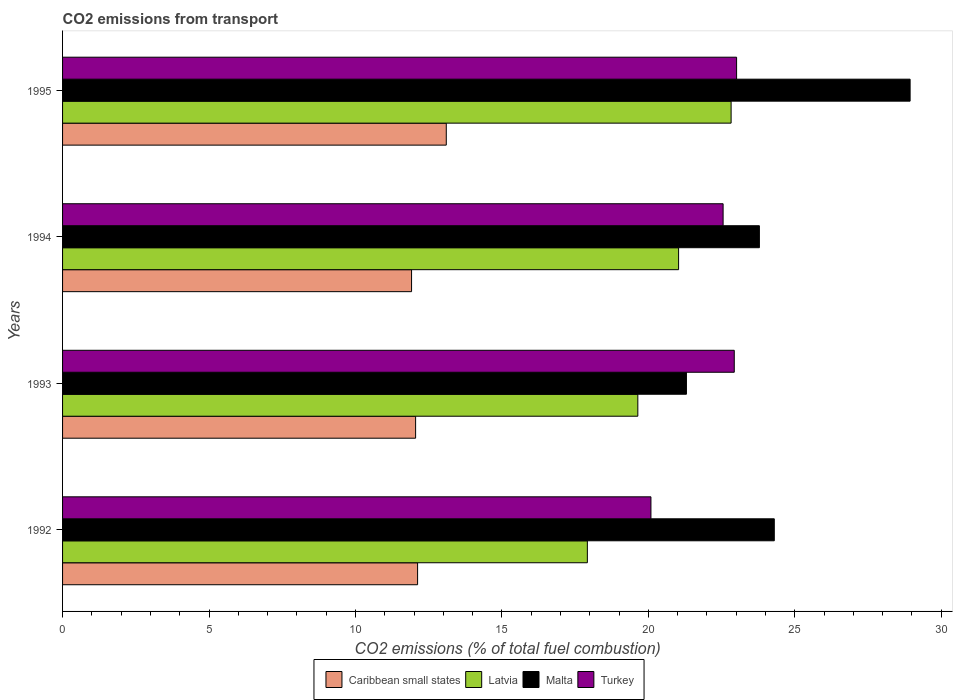How many different coloured bars are there?
Give a very brief answer. 4. How many groups of bars are there?
Offer a very short reply. 4. How many bars are there on the 4th tick from the top?
Offer a terse response. 4. What is the total CO2 emitted in Caribbean small states in 1994?
Provide a short and direct response. 11.92. Across all years, what is the maximum total CO2 emitted in Latvia?
Your answer should be compact. 22.82. Across all years, what is the minimum total CO2 emitted in Caribbean small states?
Your response must be concise. 11.92. In which year was the total CO2 emitted in Malta minimum?
Your answer should be very brief. 1993. What is the total total CO2 emitted in Turkey in the graph?
Your answer should be very brief. 88.58. What is the difference between the total CO2 emitted in Latvia in 1992 and that in 1993?
Ensure brevity in your answer.  -1.72. What is the difference between the total CO2 emitted in Latvia in 1994 and the total CO2 emitted in Malta in 1993?
Provide a succinct answer. -0.27. What is the average total CO2 emitted in Turkey per year?
Make the answer very short. 22.15. In the year 1994, what is the difference between the total CO2 emitted in Caribbean small states and total CO2 emitted in Latvia?
Provide a short and direct response. -9.12. What is the ratio of the total CO2 emitted in Malta in 1993 to that in 1995?
Keep it short and to the point. 0.74. Is the total CO2 emitted in Caribbean small states in 1993 less than that in 1994?
Keep it short and to the point. No. Is the difference between the total CO2 emitted in Caribbean small states in 1993 and 1994 greater than the difference between the total CO2 emitted in Latvia in 1993 and 1994?
Offer a very short reply. Yes. What is the difference between the highest and the second highest total CO2 emitted in Malta?
Provide a short and direct response. 4.64. What is the difference between the highest and the lowest total CO2 emitted in Latvia?
Your answer should be very brief. 4.91. Is the sum of the total CO2 emitted in Turkey in 1992 and 1995 greater than the maximum total CO2 emitted in Latvia across all years?
Provide a short and direct response. Yes. What does the 3rd bar from the top in 1995 represents?
Your response must be concise. Latvia. What does the 1st bar from the bottom in 1992 represents?
Provide a short and direct response. Caribbean small states. Are the values on the major ticks of X-axis written in scientific E-notation?
Your answer should be compact. No. Does the graph contain any zero values?
Give a very brief answer. No. Where does the legend appear in the graph?
Ensure brevity in your answer.  Bottom center. How are the legend labels stacked?
Your answer should be compact. Horizontal. What is the title of the graph?
Provide a short and direct response. CO2 emissions from transport. What is the label or title of the X-axis?
Keep it short and to the point. CO2 emissions (% of total fuel combustion). What is the label or title of the Y-axis?
Ensure brevity in your answer.  Years. What is the CO2 emissions (% of total fuel combustion) in Caribbean small states in 1992?
Ensure brevity in your answer.  12.12. What is the CO2 emissions (% of total fuel combustion) in Latvia in 1992?
Make the answer very short. 17.92. What is the CO2 emissions (% of total fuel combustion) of Malta in 1992?
Keep it short and to the point. 24.3. What is the CO2 emissions (% of total fuel combustion) of Turkey in 1992?
Ensure brevity in your answer.  20.09. What is the CO2 emissions (% of total fuel combustion) in Caribbean small states in 1993?
Give a very brief answer. 12.05. What is the CO2 emissions (% of total fuel combustion) of Latvia in 1993?
Make the answer very short. 19.64. What is the CO2 emissions (% of total fuel combustion) of Malta in 1993?
Offer a terse response. 21.3. What is the CO2 emissions (% of total fuel combustion) in Turkey in 1993?
Make the answer very short. 22.93. What is the CO2 emissions (% of total fuel combustion) in Caribbean small states in 1994?
Offer a terse response. 11.92. What is the CO2 emissions (% of total fuel combustion) of Latvia in 1994?
Your answer should be very brief. 21.03. What is the CO2 emissions (% of total fuel combustion) of Malta in 1994?
Offer a terse response. 23.79. What is the CO2 emissions (% of total fuel combustion) in Turkey in 1994?
Provide a short and direct response. 22.55. What is the CO2 emissions (% of total fuel combustion) in Caribbean small states in 1995?
Offer a terse response. 13.1. What is the CO2 emissions (% of total fuel combustion) of Latvia in 1995?
Your response must be concise. 22.82. What is the CO2 emissions (% of total fuel combustion) of Malta in 1995?
Your response must be concise. 28.94. What is the CO2 emissions (% of total fuel combustion) of Turkey in 1995?
Your answer should be compact. 23.01. Across all years, what is the maximum CO2 emissions (% of total fuel combustion) of Caribbean small states?
Your answer should be compact. 13.1. Across all years, what is the maximum CO2 emissions (% of total fuel combustion) in Latvia?
Provide a succinct answer. 22.82. Across all years, what is the maximum CO2 emissions (% of total fuel combustion) of Malta?
Provide a succinct answer. 28.94. Across all years, what is the maximum CO2 emissions (% of total fuel combustion) in Turkey?
Keep it short and to the point. 23.01. Across all years, what is the minimum CO2 emissions (% of total fuel combustion) in Caribbean small states?
Provide a succinct answer. 11.92. Across all years, what is the minimum CO2 emissions (% of total fuel combustion) in Latvia?
Offer a very short reply. 17.92. Across all years, what is the minimum CO2 emissions (% of total fuel combustion) in Malta?
Give a very brief answer. 21.3. Across all years, what is the minimum CO2 emissions (% of total fuel combustion) in Turkey?
Your response must be concise. 20.09. What is the total CO2 emissions (% of total fuel combustion) in Caribbean small states in the graph?
Your answer should be very brief. 49.19. What is the total CO2 emissions (% of total fuel combustion) in Latvia in the graph?
Offer a terse response. 81.41. What is the total CO2 emissions (% of total fuel combustion) of Malta in the graph?
Make the answer very short. 98.33. What is the total CO2 emissions (% of total fuel combustion) of Turkey in the graph?
Offer a terse response. 88.58. What is the difference between the CO2 emissions (% of total fuel combustion) of Caribbean small states in 1992 and that in 1993?
Provide a short and direct response. 0.07. What is the difference between the CO2 emissions (% of total fuel combustion) in Latvia in 1992 and that in 1993?
Your answer should be compact. -1.72. What is the difference between the CO2 emissions (% of total fuel combustion) of Malta in 1992 and that in 1993?
Ensure brevity in your answer.  3. What is the difference between the CO2 emissions (% of total fuel combustion) in Turkey in 1992 and that in 1993?
Your answer should be very brief. -2.84. What is the difference between the CO2 emissions (% of total fuel combustion) of Caribbean small states in 1992 and that in 1994?
Your answer should be very brief. 0.21. What is the difference between the CO2 emissions (% of total fuel combustion) in Latvia in 1992 and that in 1994?
Provide a succinct answer. -3.11. What is the difference between the CO2 emissions (% of total fuel combustion) of Malta in 1992 and that in 1994?
Ensure brevity in your answer.  0.51. What is the difference between the CO2 emissions (% of total fuel combustion) of Turkey in 1992 and that in 1994?
Your answer should be very brief. -2.46. What is the difference between the CO2 emissions (% of total fuel combustion) of Caribbean small states in 1992 and that in 1995?
Make the answer very short. -0.98. What is the difference between the CO2 emissions (% of total fuel combustion) of Latvia in 1992 and that in 1995?
Ensure brevity in your answer.  -4.91. What is the difference between the CO2 emissions (% of total fuel combustion) of Malta in 1992 and that in 1995?
Your answer should be compact. -4.64. What is the difference between the CO2 emissions (% of total fuel combustion) of Turkey in 1992 and that in 1995?
Provide a short and direct response. -2.92. What is the difference between the CO2 emissions (% of total fuel combustion) of Caribbean small states in 1993 and that in 1994?
Your answer should be compact. 0.14. What is the difference between the CO2 emissions (% of total fuel combustion) of Latvia in 1993 and that in 1994?
Give a very brief answer. -1.39. What is the difference between the CO2 emissions (% of total fuel combustion) of Malta in 1993 and that in 1994?
Your response must be concise. -2.49. What is the difference between the CO2 emissions (% of total fuel combustion) in Turkey in 1993 and that in 1994?
Provide a short and direct response. 0.38. What is the difference between the CO2 emissions (% of total fuel combustion) in Caribbean small states in 1993 and that in 1995?
Provide a short and direct response. -1.05. What is the difference between the CO2 emissions (% of total fuel combustion) in Latvia in 1993 and that in 1995?
Ensure brevity in your answer.  -3.19. What is the difference between the CO2 emissions (% of total fuel combustion) of Malta in 1993 and that in 1995?
Offer a very short reply. -7.64. What is the difference between the CO2 emissions (% of total fuel combustion) in Turkey in 1993 and that in 1995?
Offer a very short reply. -0.08. What is the difference between the CO2 emissions (% of total fuel combustion) in Caribbean small states in 1994 and that in 1995?
Provide a succinct answer. -1.19. What is the difference between the CO2 emissions (% of total fuel combustion) in Latvia in 1994 and that in 1995?
Offer a terse response. -1.79. What is the difference between the CO2 emissions (% of total fuel combustion) in Malta in 1994 and that in 1995?
Offer a terse response. -5.15. What is the difference between the CO2 emissions (% of total fuel combustion) of Turkey in 1994 and that in 1995?
Make the answer very short. -0.46. What is the difference between the CO2 emissions (% of total fuel combustion) of Caribbean small states in 1992 and the CO2 emissions (% of total fuel combustion) of Latvia in 1993?
Give a very brief answer. -7.52. What is the difference between the CO2 emissions (% of total fuel combustion) in Caribbean small states in 1992 and the CO2 emissions (% of total fuel combustion) in Malta in 1993?
Make the answer very short. -9.18. What is the difference between the CO2 emissions (% of total fuel combustion) of Caribbean small states in 1992 and the CO2 emissions (% of total fuel combustion) of Turkey in 1993?
Provide a short and direct response. -10.81. What is the difference between the CO2 emissions (% of total fuel combustion) in Latvia in 1992 and the CO2 emissions (% of total fuel combustion) in Malta in 1993?
Keep it short and to the point. -3.38. What is the difference between the CO2 emissions (% of total fuel combustion) in Latvia in 1992 and the CO2 emissions (% of total fuel combustion) in Turkey in 1993?
Your answer should be compact. -5.02. What is the difference between the CO2 emissions (% of total fuel combustion) of Malta in 1992 and the CO2 emissions (% of total fuel combustion) of Turkey in 1993?
Your response must be concise. 1.37. What is the difference between the CO2 emissions (% of total fuel combustion) in Caribbean small states in 1992 and the CO2 emissions (% of total fuel combustion) in Latvia in 1994?
Your answer should be compact. -8.91. What is the difference between the CO2 emissions (% of total fuel combustion) in Caribbean small states in 1992 and the CO2 emissions (% of total fuel combustion) in Malta in 1994?
Give a very brief answer. -11.67. What is the difference between the CO2 emissions (% of total fuel combustion) in Caribbean small states in 1992 and the CO2 emissions (% of total fuel combustion) in Turkey in 1994?
Make the answer very short. -10.43. What is the difference between the CO2 emissions (% of total fuel combustion) of Latvia in 1992 and the CO2 emissions (% of total fuel combustion) of Malta in 1994?
Make the answer very short. -5.87. What is the difference between the CO2 emissions (% of total fuel combustion) in Latvia in 1992 and the CO2 emissions (% of total fuel combustion) in Turkey in 1994?
Ensure brevity in your answer.  -4.63. What is the difference between the CO2 emissions (% of total fuel combustion) in Malta in 1992 and the CO2 emissions (% of total fuel combustion) in Turkey in 1994?
Offer a very short reply. 1.75. What is the difference between the CO2 emissions (% of total fuel combustion) of Caribbean small states in 1992 and the CO2 emissions (% of total fuel combustion) of Latvia in 1995?
Ensure brevity in your answer.  -10.7. What is the difference between the CO2 emissions (% of total fuel combustion) of Caribbean small states in 1992 and the CO2 emissions (% of total fuel combustion) of Malta in 1995?
Give a very brief answer. -16.82. What is the difference between the CO2 emissions (% of total fuel combustion) in Caribbean small states in 1992 and the CO2 emissions (% of total fuel combustion) in Turkey in 1995?
Keep it short and to the point. -10.89. What is the difference between the CO2 emissions (% of total fuel combustion) in Latvia in 1992 and the CO2 emissions (% of total fuel combustion) in Malta in 1995?
Offer a terse response. -11.02. What is the difference between the CO2 emissions (% of total fuel combustion) of Latvia in 1992 and the CO2 emissions (% of total fuel combustion) of Turkey in 1995?
Your answer should be very brief. -5.09. What is the difference between the CO2 emissions (% of total fuel combustion) of Malta in 1992 and the CO2 emissions (% of total fuel combustion) of Turkey in 1995?
Provide a succinct answer. 1.29. What is the difference between the CO2 emissions (% of total fuel combustion) of Caribbean small states in 1993 and the CO2 emissions (% of total fuel combustion) of Latvia in 1994?
Give a very brief answer. -8.98. What is the difference between the CO2 emissions (% of total fuel combustion) in Caribbean small states in 1993 and the CO2 emissions (% of total fuel combustion) in Malta in 1994?
Your answer should be very brief. -11.74. What is the difference between the CO2 emissions (% of total fuel combustion) of Caribbean small states in 1993 and the CO2 emissions (% of total fuel combustion) of Turkey in 1994?
Offer a terse response. -10.5. What is the difference between the CO2 emissions (% of total fuel combustion) in Latvia in 1993 and the CO2 emissions (% of total fuel combustion) in Malta in 1994?
Make the answer very short. -4.15. What is the difference between the CO2 emissions (% of total fuel combustion) in Latvia in 1993 and the CO2 emissions (% of total fuel combustion) in Turkey in 1994?
Give a very brief answer. -2.91. What is the difference between the CO2 emissions (% of total fuel combustion) of Malta in 1993 and the CO2 emissions (% of total fuel combustion) of Turkey in 1994?
Offer a terse response. -1.25. What is the difference between the CO2 emissions (% of total fuel combustion) of Caribbean small states in 1993 and the CO2 emissions (% of total fuel combustion) of Latvia in 1995?
Your answer should be very brief. -10.77. What is the difference between the CO2 emissions (% of total fuel combustion) in Caribbean small states in 1993 and the CO2 emissions (% of total fuel combustion) in Malta in 1995?
Keep it short and to the point. -16.88. What is the difference between the CO2 emissions (% of total fuel combustion) of Caribbean small states in 1993 and the CO2 emissions (% of total fuel combustion) of Turkey in 1995?
Give a very brief answer. -10.96. What is the difference between the CO2 emissions (% of total fuel combustion) in Latvia in 1993 and the CO2 emissions (% of total fuel combustion) in Malta in 1995?
Provide a short and direct response. -9.3. What is the difference between the CO2 emissions (% of total fuel combustion) in Latvia in 1993 and the CO2 emissions (% of total fuel combustion) in Turkey in 1995?
Offer a terse response. -3.37. What is the difference between the CO2 emissions (% of total fuel combustion) in Malta in 1993 and the CO2 emissions (% of total fuel combustion) in Turkey in 1995?
Offer a very short reply. -1.71. What is the difference between the CO2 emissions (% of total fuel combustion) in Caribbean small states in 1994 and the CO2 emissions (% of total fuel combustion) in Latvia in 1995?
Your answer should be compact. -10.91. What is the difference between the CO2 emissions (% of total fuel combustion) in Caribbean small states in 1994 and the CO2 emissions (% of total fuel combustion) in Malta in 1995?
Make the answer very short. -17.02. What is the difference between the CO2 emissions (% of total fuel combustion) in Caribbean small states in 1994 and the CO2 emissions (% of total fuel combustion) in Turkey in 1995?
Give a very brief answer. -11.1. What is the difference between the CO2 emissions (% of total fuel combustion) of Latvia in 1994 and the CO2 emissions (% of total fuel combustion) of Malta in 1995?
Offer a terse response. -7.9. What is the difference between the CO2 emissions (% of total fuel combustion) in Latvia in 1994 and the CO2 emissions (% of total fuel combustion) in Turkey in 1995?
Offer a terse response. -1.98. What is the difference between the CO2 emissions (% of total fuel combustion) in Malta in 1994 and the CO2 emissions (% of total fuel combustion) in Turkey in 1995?
Provide a short and direct response. 0.78. What is the average CO2 emissions (% of total fuel combustion) of Caribbean small states per year?
Your response must be concise. 12.3. What is the average CO2 emissions (% of total fuel combustion) of Latvia per year?
Offer a terse response. 20.35. What is the average CO2 emissions (% of total fuel combustion) in Malta per year?
Provide a succinct answer. 24.58. What is the average CO2 emissions (% of total fuel combustion) in Turkey per year?
Offer a terse response. 22.15. In the year 1992, what is the difference between the CO2 emissions (% of total fuel combustion) in Caribbean small states and CO2 emissions (% of total fuel combustion) in Latvia?
Offer a terse response. -5.8. In the year 1992, what is the difference between the CO2 emissions (% of total fuel combustion) in Caribbean small states and CO2 emissions (% of total fuel combustion) in Malta?
Provide a short and direct response. -12.18. In the year 1992, what is the difference between the CO2 emissions (% of total fuel combustion) in Caribbean small states and CO2 emissions (% of total fuel combustion) in Turkey?
Provide a succinct answer. -7.97. In the year 1992, what is the difference between the CO2 emissions (% of total fuel combustion) in Latvia and CO2 emissions (% of total fuel combustion) in Malta?
Your answer should be very brief. -6.38. In the year 1992, what is the difference between the CO2 emissions (% of total fuel combustion) of Latvia and CO2 emissions (% of total fuel combustion) of Turkey?
Give a very brief answer. -2.17. In the year 1992, what is the difference between the CO2 emissions (% of total fuel combustion) of Malta and CO2 emissions (% of total fuel combustion) of Turkey?
Ensure brevity in your answer.  4.21. In the year 1993, what is the difference between the CO2 emissions (% of total fuel combustion) of Caribbean small states and CO2 emissions (% of total fuel combustion) of Latvia?
Ensure brevity in your answer.  -7.59. In the year 1993, what is the difference between the CO2 emissions (% of total fuel combustion) in Caribbean small states and CO2 emissions (% of total fuel combustion) in Malta?
Ensure brevity in your answer.  -9.25. In the year 1993, what is the difference between the CO2 emissions (% of total fuel combustion) of Caribbean small states and CO2 emissions (% of total fuel combustion) of Turkey?
Provide a succinct answer. -10.88. In the year 1993, what is the difference between the CO2 emissions (% of total fuel combustion) in Latvia and CO2 emissions (% of total fuel combustion) in Malta?
Your answer should be compact. -1.66. In the year 1993, what is the difference between the CO2 emissions (% of total fuel combustion) in Latvia and CO2 emissions (% of total fuel combustion) in Turkey?
Provide a succinct answer. -3.29. In the year 1993, what is the difference between the CO2 emissions (% of total fuel combustion) of Malta and CO2 emissions (% of total fuel combustion) of Turkey?
Give a very brief answer. -1.63. In the year 1994, what is the difference between the CO2 emissions (% of total fuel combustion) in Caribbean small states and CO2 emissions (% of total fuel combustion) in Latvia?
Offer a very short reply. -9.12. In the year 1994, what is the difference between the CO2 emissions (% of total fuel combustion) of Caribbean small states and CO2 emissions (% of total fuel combustion) of Malta?
Make the answer very short. -11.88. In the year 1994, what is the difference between the CO2 emissions (% of total fuel combustion) of Caribbean small states and CO2 emissions (% of total fuel combustion) of Turkey?
Ensure brevity in your answer.  -10.64. In the year 1994, what is the difference between the CO2 emissions (% of total fuel combustion) in Latvia and CO2 emissions (% of total fuel combustion) in Malta?
Make the answer very short. -2.76. In the year 1994, what is the difference between the CO2 emissions (% of total fuel combustion) in Latvia and CO2 emissions (% of total fuel combustion) in Turkey?
Provide a succinct answer. -1.52. In the year 1994, what is the difference between the CO2 emissions (% of total fuel combustion) of Malta and CO2 emissions (% of total fuel combustion) of Turkey?
Your response must be concise. 1.24. In the year 1995, what is the difference between the CO2 emissions (% of total fuel combustion) in Caribbean small states and CO2 emissions (% of total fuel combustion) in Latvia?
Make the answer very short. -9.72. In the year 1995, what is the difference between the CO2 emissions (% of total fuel combustion) in Caribbean small states and CO2 emissions (% of total fuel combustion) in Malta?
Offer a terse response. -15.84. In the year 1995, what is the difference between the CO2 emissions (% of total fuel combustion) in Caribbean small states and CO2 emissions (% of total fuel combustion) in Turkey?
Offer a very short reply. -9.91. In the year 1995, what is the difference between the CO2 emissions (% of total fuel combustion) in Latvia and CO2 emissions (% of total fuel combustion) in Malta?
Provide a succinct answer. -6.11. In the year 1995, what is the difference between the CO2 emissions (% of total fuel combustion) of Latvia and CO2 emissions (% of total fuel combustion) of Turkey?
Give a very brief answer. -0.19. In the year 1995, what is the difference between the CO2 emissions (% of total fuel combustion) in Malta and CO2 emissions (% of total fuel combustion) in Turkey?
Provide a succinct answer. 5.92. What is the ratio of the CO2 emissions (% of total fuel combustion) in Caribbean small states in 1992 to that in 1993?
Offer a terse response. 1.01. What is the ratio of the CO2 emissions (% of total fuel combustion) in Latvia in 1992 to that in 1993?
Your answer should be compact. 0.91. What is the ratio of the CO2 emissions (% of total fuel combustion) of Malta in 1992 to that in 1993?
Offer a terse response. 1.14. What is the ratio of the CO2 emissions (% of total fuel combustion) in Turkey in 1992 to that in 1993?
Offer a terse response. 0.88. What is the ratio of the CO2 emissions (% of total fuel combustion) in Caribbean small states in 1992 to that in 1994?
Offer a very short reply. 1.02. What is the ratio of the CO2 emissions (% of total fuel combustion) of Latvia in 1992 to that in 1994?
Provide a succinct answer. 0.85. What is the ratio of the CO2 emissions (% of total fuel combustion) in Malta in 1992 to that in 1994?
Your answer should be compact. 1.02. What is the ratio of the CO2 emissions (% of total fuel combustion) of Turkey in 1992 to that in 1994?
Provide a short and direct response. 0.89. What is the ratio of the CO2 emissions (% of total fuel combustion) of Caribbean small states in 1992 to that in 1995?
Offer a very short reply. 0.93. What is the ratio of the CO2 emissions (% of total fuel combustion) in Latvia in 1992 to that in 1995?
Your response must be concise. 0.79. What is the ratio of the CO2 emissions (% of total fuel combustion) of Malta in 1992 to that in 1995?
Ensure brevity in your answer.  0.84. What is the ratio of the CO2 emissions (% of total fuel combustion) of Turkey in 1992 to that in 1995?
Keep it short and to the point. 0.87. What is the ratio of the CO2 emissions (% of total fuel combustion) in Caribbean small states in 1993 to that in 1994?
Give a very brief answer. 1.01. What is the ratio of the CO2 emissions (% of total fuel combustion) of Latvia in 1993 to that in 1994?
Provide a succinct answer. 0.93. What is the ratio of the CO2 emissions (% of total fuel combustion) of Malta in 1993 to that in 1994?
Offer a terse response. 0.9. What is the ratio of the CO2 emissions (% of total fuel combustion) of Turkey in 1993 to that in 1994?
Your answer should be very brief. 1.02. What is the ratio of the CO2 emissions (% of total fuel combustion) in Caribbean small states in 1993 to that in 1995?
Your answer should be very brief. 0.92. What is the ratio of the CO2 emissions (% of total fuel combustion) in Latvia in 1993 to that in 1995?
Keep it short and to the point. 0.86. What is the ratio of the CO2 emissions (% of total fuel combustion) of Malta in 1993 to that in 1995?
Keep it short and to the point. 0.74. What is the ratio of the CO2 emissions (% of total fuel combustion) of Caribbean small states in 1994 to that in 1995?
Provide a succinct answer. 0.91. What is the ratio of the CO2 emissions (% of total fuel combustion) of Latvia in 1994 to that in 1995?
Provide a short and direct response. 0.92. What is the ratio of the CO2 emissions (% of total fuel combustion) of Malta in 1994 to that in 1995?
Ensure brevity in your answer.  0.82. What is the difference between the highest and the second highest CO2 emissions (% of total fuel combustion) of Caribbean small states?
Ensure brevity in your answer.  0.98. What is the difference between the highest and the second highest CO2 emissions (% of total fuel combustion) of Latvia?
Ensure brevity in your answer.  1.79. What is the difference between the highest and the second highest CO2 emissions (% of total fuel combustion) in Malta?
Your response must be concise. 4.64. What is the difference between the highest and the second highest CO2 emissions (% of total fuel combustion) in Turkey?
Your response must be concise. 0.08. What is the difference between the highest and the lowest CO2 emissions (% of total fuel combustion) of Caribbean small states?
Your response must be concise. 1.19. What is the difference between the highest and the lowest CO2 emissions (% of total fuel combustion) of Latvia?
Ensure brevity in your answer.  4.91. What is the difference between the highest and the lowest CO2 emissions (% of total fuel combustion) of Malta?
Your response must be concise. 7.64. What is the difference between the highest and the lowest CO2 emissions (% of total fuel combustion) of Turkey?
Give a very brief answer. 2.92. 